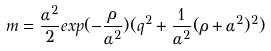Convert formula to latex. <formula><loc_0><loc_0><loc_500><loc_500>m = { \frac { \alpha ^ { 2 } } { 2 } } e x p ( - { \frac { \rho } { \alpha ^ { 2 } } } ) ( q ^ { 2 } + { \frac { 1 } { \alpha ^ { 2 } } } ( \rho + { \alpha ^ { 2 } } ) ^ { 2 } )</formula> 